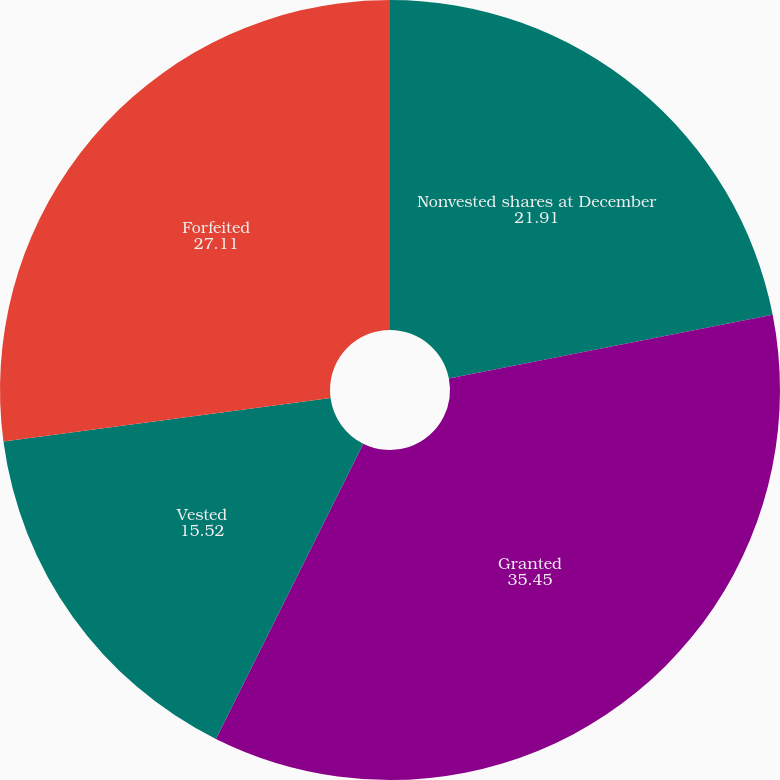Convert chart to OTSL. <chart><loc_0><loc_0><loc_500><loc_500><pie_chart><fcel>Nonvested shares at December<fcel>Granted<fcel>Vested<fcel>Forfeited<nl><fcel>21.91%<fcel>35.45%<fcel>15.52%<fcel>27.11%<nl></chart> 